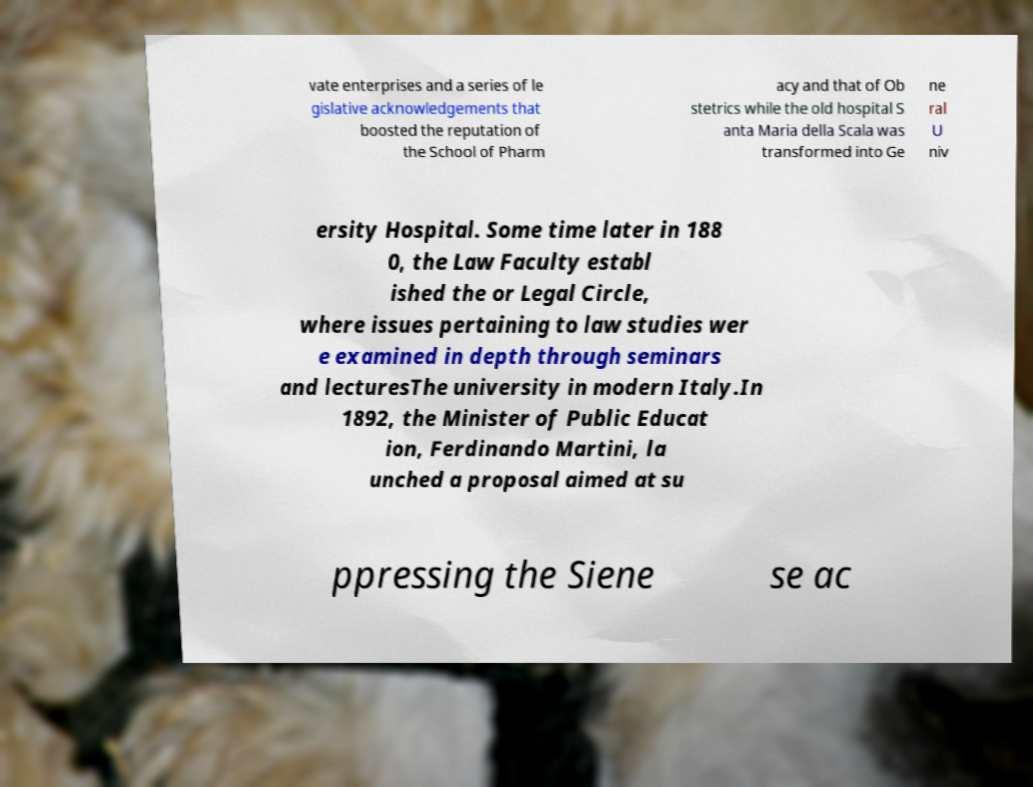There's text embedded in this image that I need extracted. Can you transcribe it verbatim? vate enterprises and a series of le gislative acknowledgements that boosted the reputation of the School of Pharm acy and that of Ob stetrics while the old hospital S anta Maria della Scala was transformed into Ge ne ral U niv ersity Hospital. Some time later in 188 0, the Law Faculty establ ished the or Legal Circle, where issues pertaining to law studies wer e examined in depth through seminars and lecturesThe university in modern Italy.In 1892, the Minister of Public Educat ion, Ferdinando Martini, la unched a proposal aimed at su ppressing the Siene se ac 